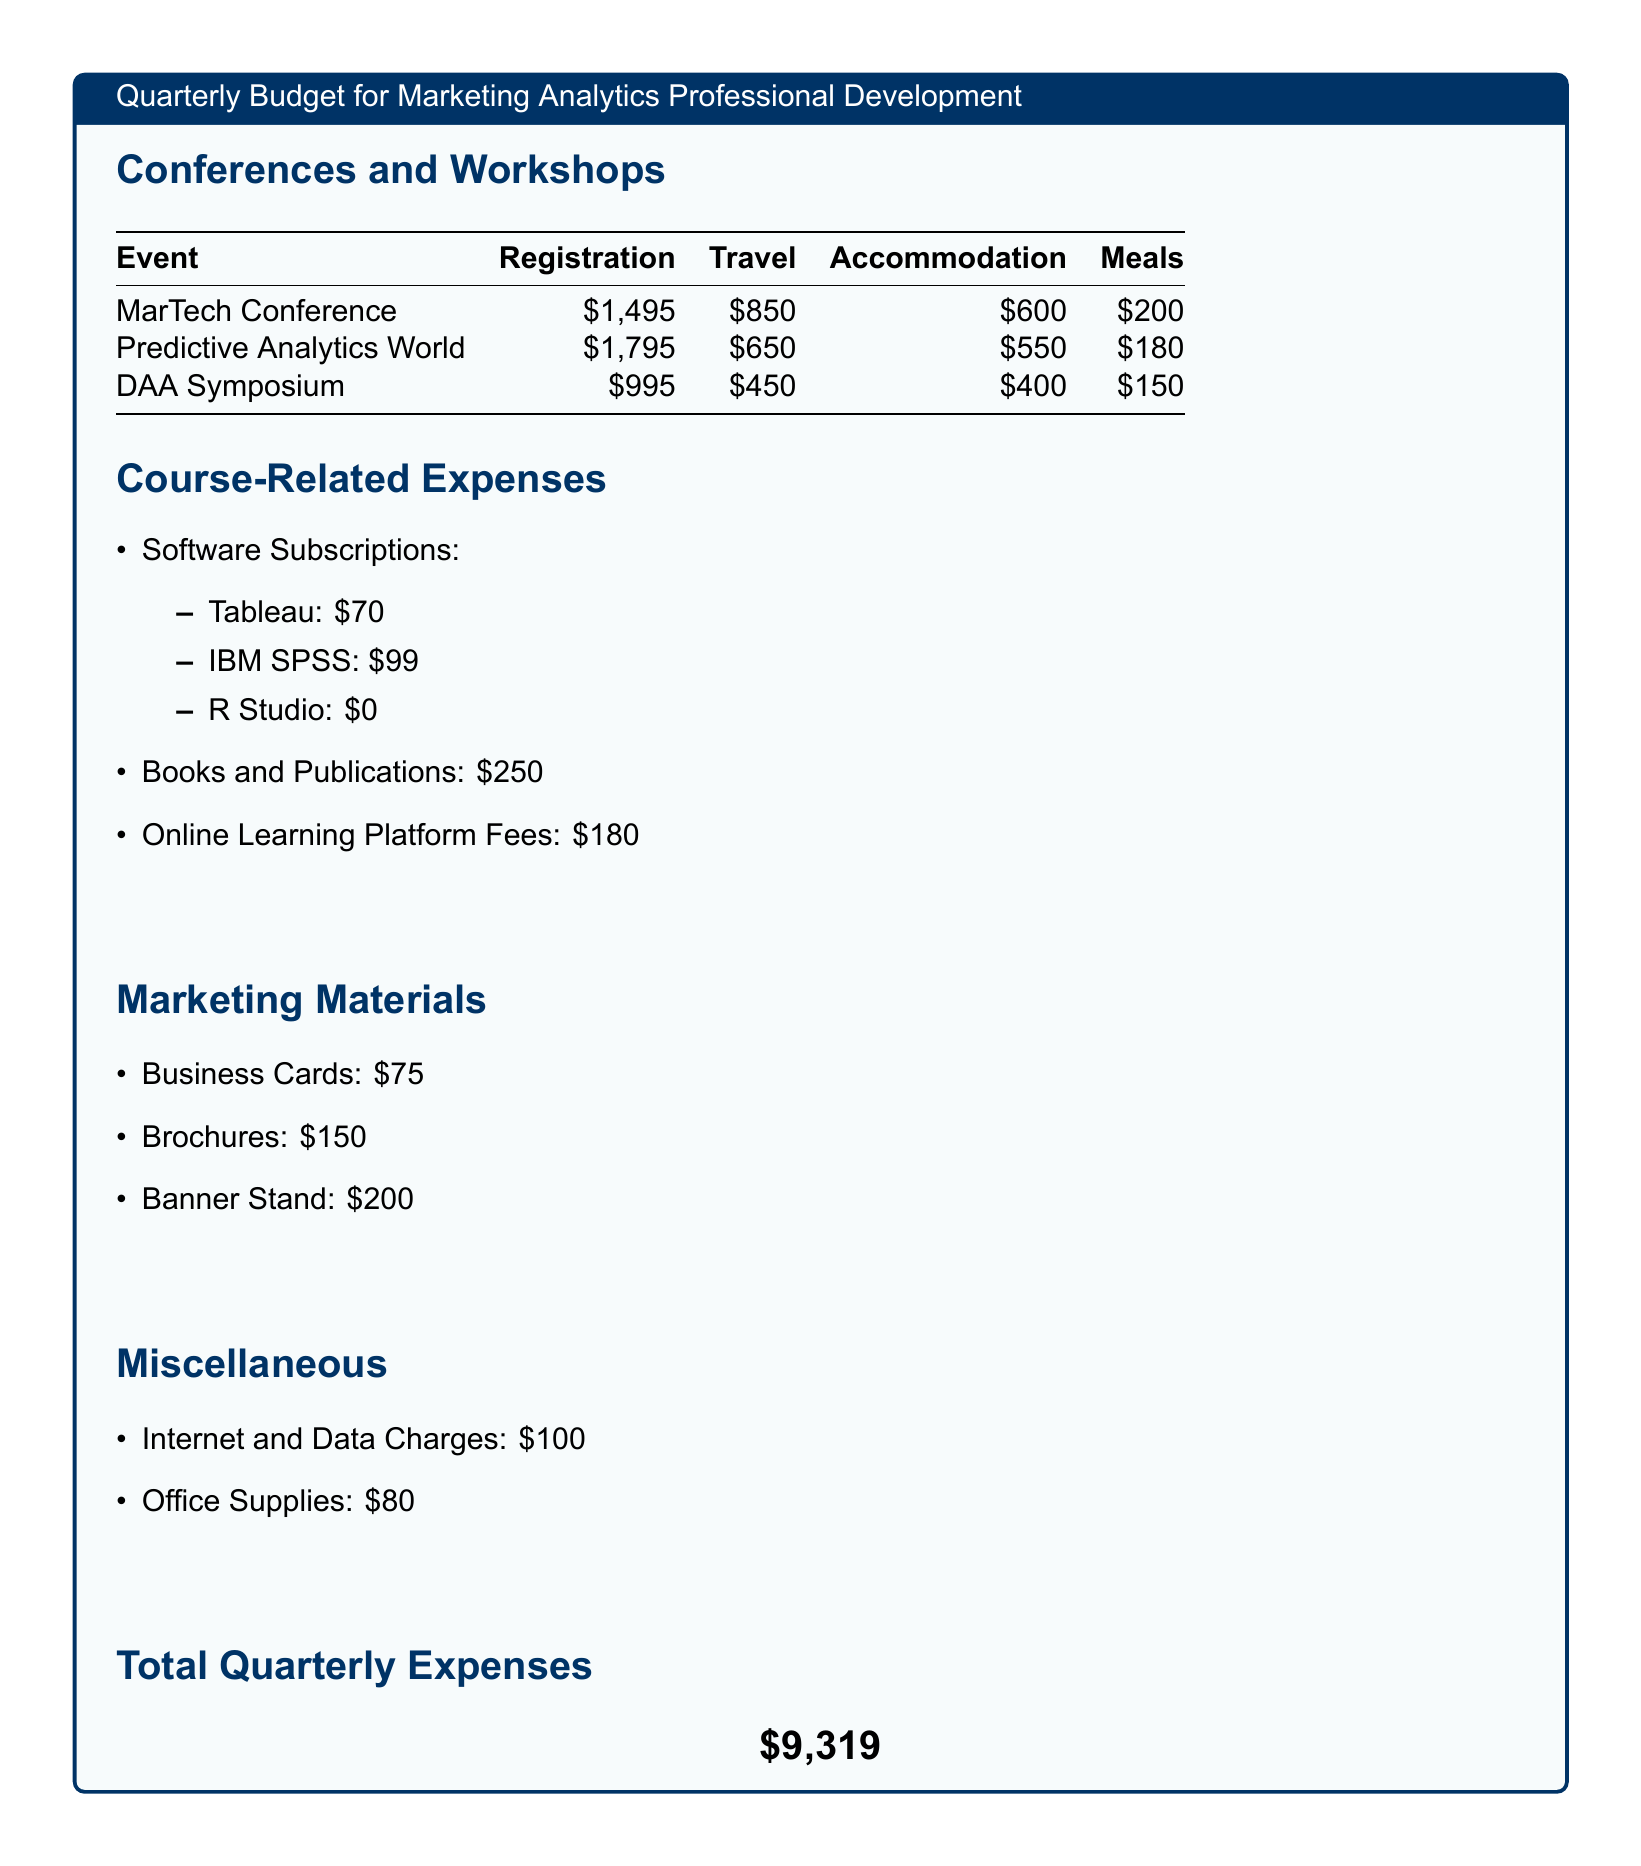What is the total budget for the MarTech Conference? The total budget for the MarTech Conference includes registration, travel, accommodation, and meals: $1495 + $850 + $600 + $200 = $3145.
Answer: $3145 How much is allocated for online learning platform fees? The online learning platform fees listed in the document is a specific course-related expense amounting to $180.
Answer: $180 What is the cost of the DAA Symposium registration? The registration fee for the DAA Symposium is stated directly in the table of events.
Answer: $995 What is the total quarterly expense amount? The total quarterly expenses is provided at the bottom of the document, which is the sum of all expenses listed.
Answer: $9,319 How much was spent on meals for the Predictive Analytics World? The document indicates the meals expense specifically allocated for the Predictive Analytics World event is $180.
Answer: $180 What is the sum of the travel expenses for all listed conferences? The sum of the travel expenses requires adding each conference's travel expense together: $850 + $650 + $450 = $1950.
Answer: $1950 How much is spent on business cards? The cost for business cards is provided as part of the marketing materials section in the document.
Answer: $75 Which software subscription is free? The document lists the software subscriptions, and R Studio is specifically noted as $0, indicating it has no cost.
Answer: R Studio What are the total costs for marketing materials? The total cost for marketing materials is the sum of business cards, brochures, and banner stand: $75 + $150 + $200 = $425.
Answer: $425 